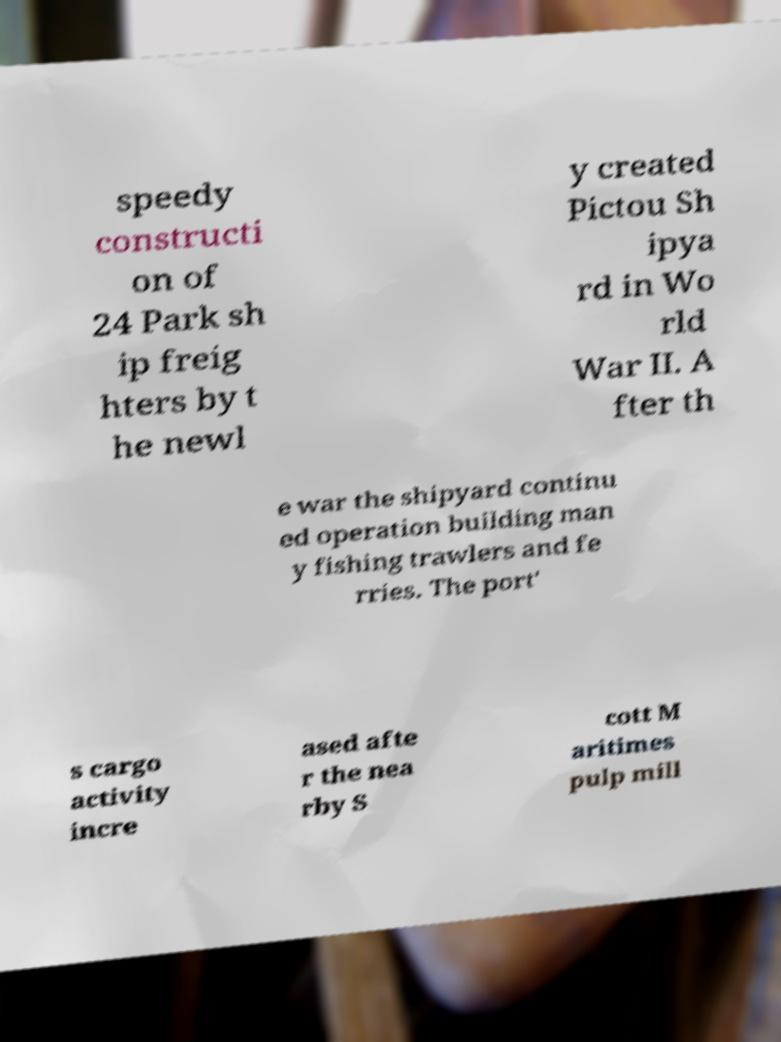What messages or text are displayed in this image? I need them in a readable, typed format. speedy constructi on of 24 Park sh ip freig hters by t he newl y created Pictou Sh ipya rd in Wo rld War II. A fter th e war the shipyard continu ed operation building man y fishing trawlers and fe rries. The port' s cargo activity incre ased afte r the nea rby S cott M aritimes pulp mill 